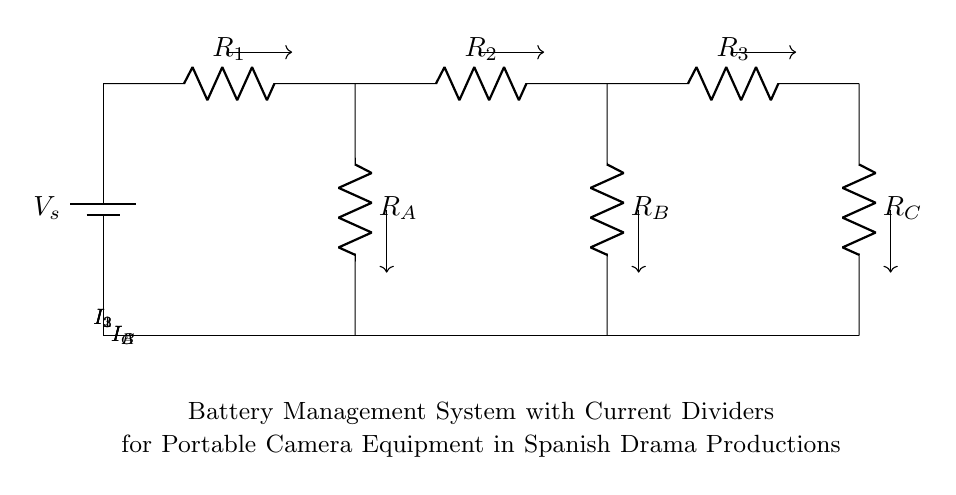What is the total resistance of the circuit? To find the total resistance in a series-parallel circuit like this, you start by identifying the resistors. The resistors R1, R2, and R3 are in series, and their total resistance is the sum R1 + R2 + R3. For the current divider branches, you would find their equivalent resistance separately and combine them accordingly. However, since the question asks for the total resistance without specifying the values, we can define it generally as R_total = R1 + R2 + R3.
Answer: R1 + R2 + R3 What is the purpose of the current dividers (R_A, R_B, R_C) in the circuit? Current dividers are used to split the current from the source between multiple paths. In this circuit, R_A, R_B, and R_C serve to direct specific amounts of current to different loads or components connected to them, which is essential in managing how power is distributed to the camera equipment.
Answer: Split current Which component has the highest current? The current in a series circuit is consistent across all components, while in parallel branches, it varies based on resistance. The current through each branch (I_A, I_B, I_C) can be calculated using the formula I = V/R. The branch with the lowest resistance will have the highest current, meaning among R_A, R_B, and R_C, the one with the lowest resistance will carry the highest current.
Answer: R_A, R_B, or R_C with lowest resistance How is the current I_A calculated? The current I_A can be calculated using Ohm's Law, where I_A = V/R_A, with V being the voltage across R_A. Since R_A is a branch that is part of a current divider, knowing the voltage from the battery (Vs) and the resistance value of R_A lets you compute the current flowing through this branch specifically.
Answer: V/R_A What happens to the current if R_B increases significantly? If R_B increases, its share of the total current will decrease. In a current divider setup, as the resistance of one branch increases, based on the current divider rule, less current will flow through that branch, resulting in a greater share of the current being directed through the other paths (R_A and R_C) as they have comparatively lower resistance.
Answer: Decreases for I_B What is the battery voltage in this system? The battery voltage, labeled as V_s, is the potential difference provided by the battery. This information is typically marked within the circuit diagram. Since it states as a component without specific numerical values, it is generally referred to as V_s here.
Answer: V_s What is the function of the ground in this circuit? The ground serves as a common reference point for the circuit. It provides a return path for the current and ensures all voltages in the circuit are referenced to this point. This is crucial for the stability of the system and helps in preventing accidental short circuits and ensuring safety.
Answer: Common reference 